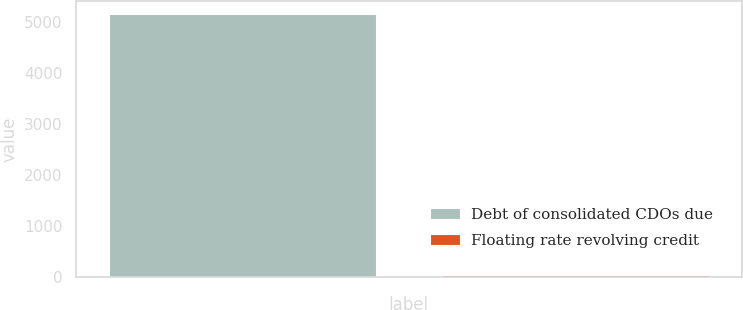Convert chart. <chart><loc_0><loc_0><loc_500><loc_500><bar_chart><fcel>Debt of consolidated CDOs due<fcel>Floating rate revolving credit<nl><fcel>5171<fcel>35<nl></chart> 